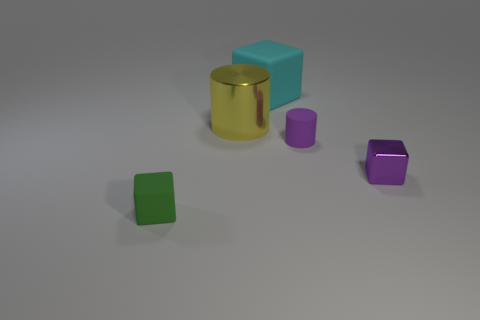There is a thing that is the same color as the small matte cylinder; what is its material?
Keep it short and to the point. Metal. How many large yellow cylinders are left of the tiny purple shiny object?
Your response must be concise. 1. There is a tiny purple thing left of the purple cube; does it have the same shape as the tiny thing in front of the purple metal thing?
Provide a short and direct response. No. How many other things are there of the same color as the large rubber thing?
Your answer should be compact. 0. There is a small object left of the cyan rubber thing that is right of the tiny block that is on the left side of the small metallic object; what is its material?
Ensure brevity in your answer.  Rubber. What material is the small object to the left of the matte cube that is on the right side of the yellow shiny cylinder made of?
Offer a very short reply. Rubber. Are there fewer large cylinders that are in front of the rubber cylinder than purple metallic objects?
Offer a very short reply. Yes. What is the shape of the tiny purple object behind the purple cube?
Ensure brevity in your answer.  Cylinder. There is a green rubber thing; does it have the same size as the cylinder on the right side of the large cyan cube?
Make the answer very short. Yes. Are there any cyan cubes made of the same material as the purple block?
Make the answer very short. No. 